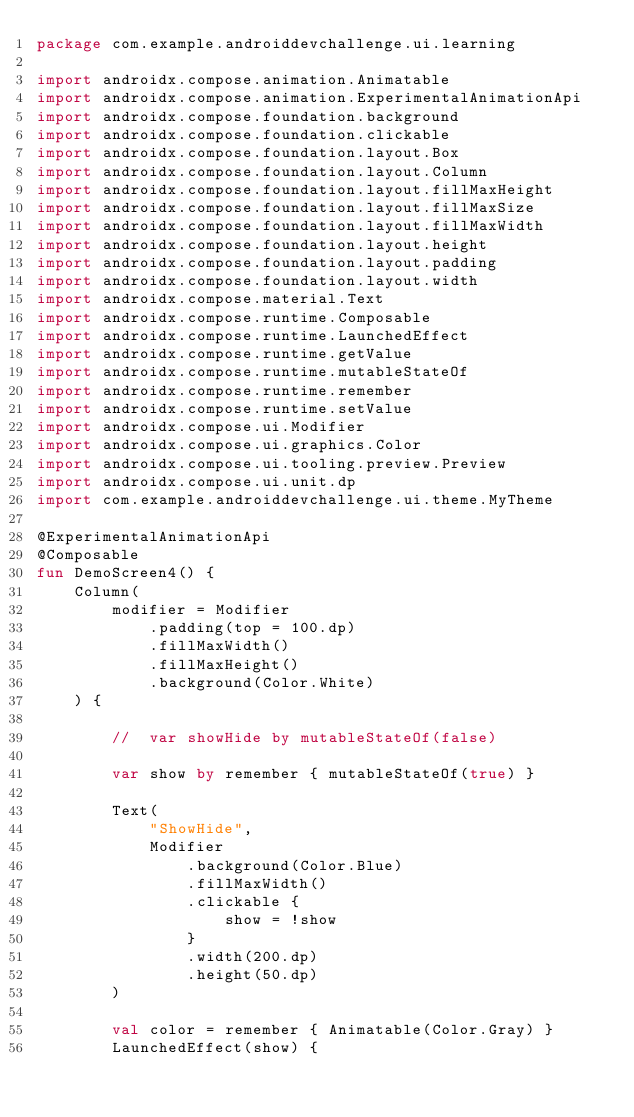<code> <loc_0><loc_0><loc_500><loc_500><_Kotlin_>package com.example.androiddevchallenge.ui.learning

import androidx.compose.animation.Animatable
import androidx.compose.animation.ExperimentalAnimationApi
import androidx.compose.foundation.background
import androidx.compose.foundation.clickable
import androidx.compose.foundation.layout.Box
import androidx.compose.foundation.layout.Column
import androidx.compose.foundation.layout.fillMaxHeight
import androidx.compose.foundation.layout.fillMaxSize
import androidx.compose.foundation.layout.fillMaxWidth
import androidx.compose.foundation.layout.height
import androidx.compose.foundation.layout.padding
import androidx.compose.foundation.layout.width
import androidx.compose.material.Text
import androidx.compose.runtime.Composable
import androidx.compose.runtime.LaunchedEffect
import androidx.compose.runtime.getValue
import androidx.compose.runtime.mutableStateOf
import androidx.compose.runtime.remember
import androidx.compose.runtime.setValue
import androidx.compose.ui.Modifier
import androidx.compose.ui.graphics.Color
import androidx.compose.ui.tooling.preview.Preview
import androidx.compose.ui.unit.dp
import com.example.androiddevchallenge.ui.theme.MyTheme

@ExperimentalAnimationApi
@Composable
fun DemoScreen4() {
    Column(
        modifier = Modifier
            .padding(top = 100.dp)
            .fillMaxWidth()
            .fillMaxHeight()
            .background(Color.White)
    ) {

        //  var showHide by mutableStateOf(false)

        var show by remember { mutableStateOf(true) }

        Text(
            "ShowHide",
            Modifier
                .background(Color.Blue)
                .fillMaxWidth()
                .clickable {
                    show = !show
                }
                .width(200.dp)
                .height(50.dp)
        )

        val color = remember { Animatable(Color.Gray) }
        LaunchedEffect(show) {</code> 